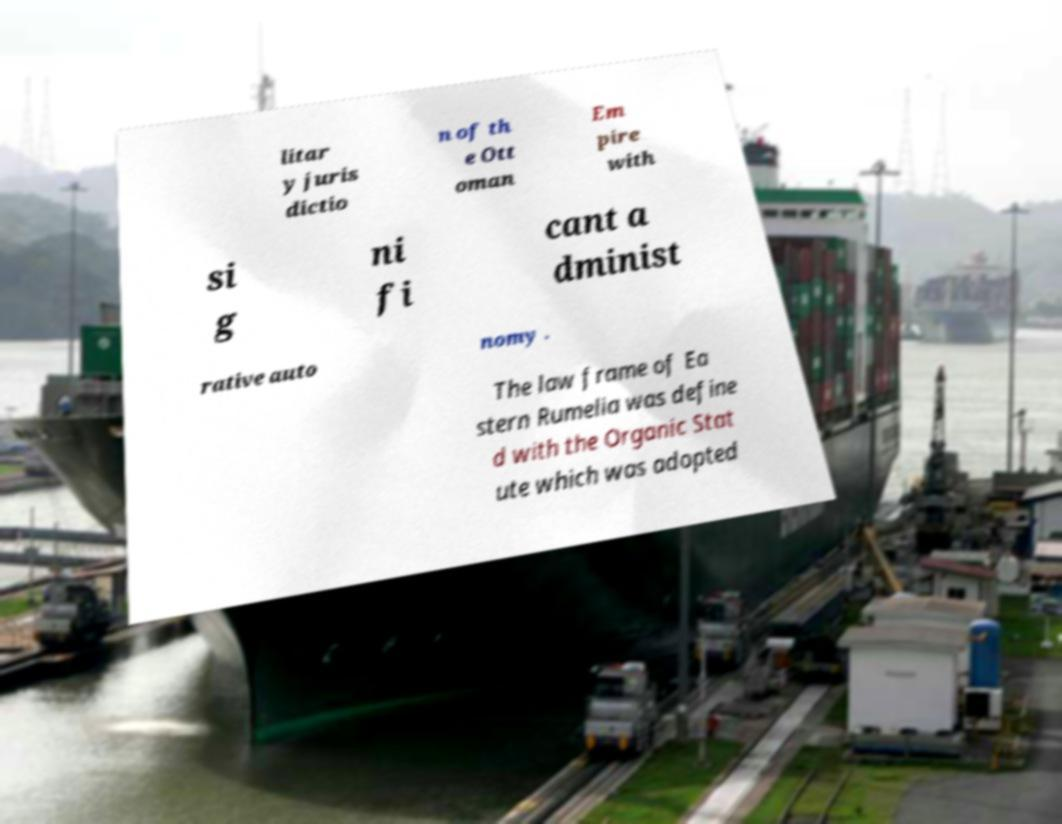There's text embedded in this image that I need extracted. Can you transcribe it verbatim? litar y juris dictio n of th e Ott oman Em pire with si g ni fi cant a dminist rative auto nomy . The law frame of Ea stern Rumelia was define d with the Organic Stat ute which was adopted 